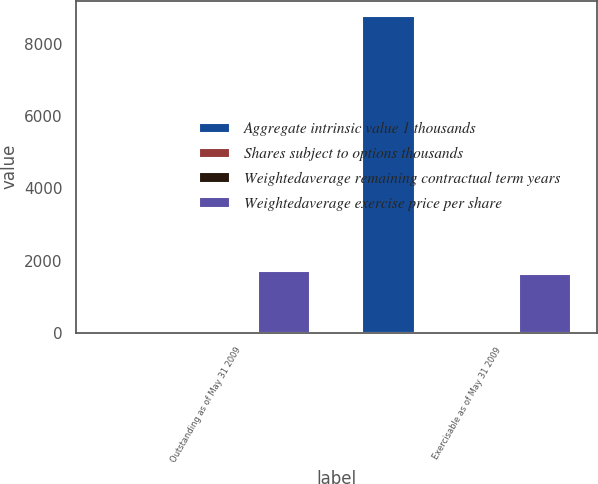Convert chart. <chart><loc_0><loc_0><loc_500><loc_500><stacked_bar_chart><ecel><fcel>Outstanding as of May 31 2009<fcel>Exercisable as of May 31 2009<nl><fcel>Aggregate intrinsic value 1 thousands<fcel>34.84<fcel>8763<nl><fcel>Shares subject to options thousands<fcel>34.84<fcel>34.38<nl><fcel>Weightedaverage remaining contractual term years<fcel>5.9<fcel>5<nl><fcel>Weightedaverage exercise price per share<fcel>1702<fcel>1627<nl></chart> 